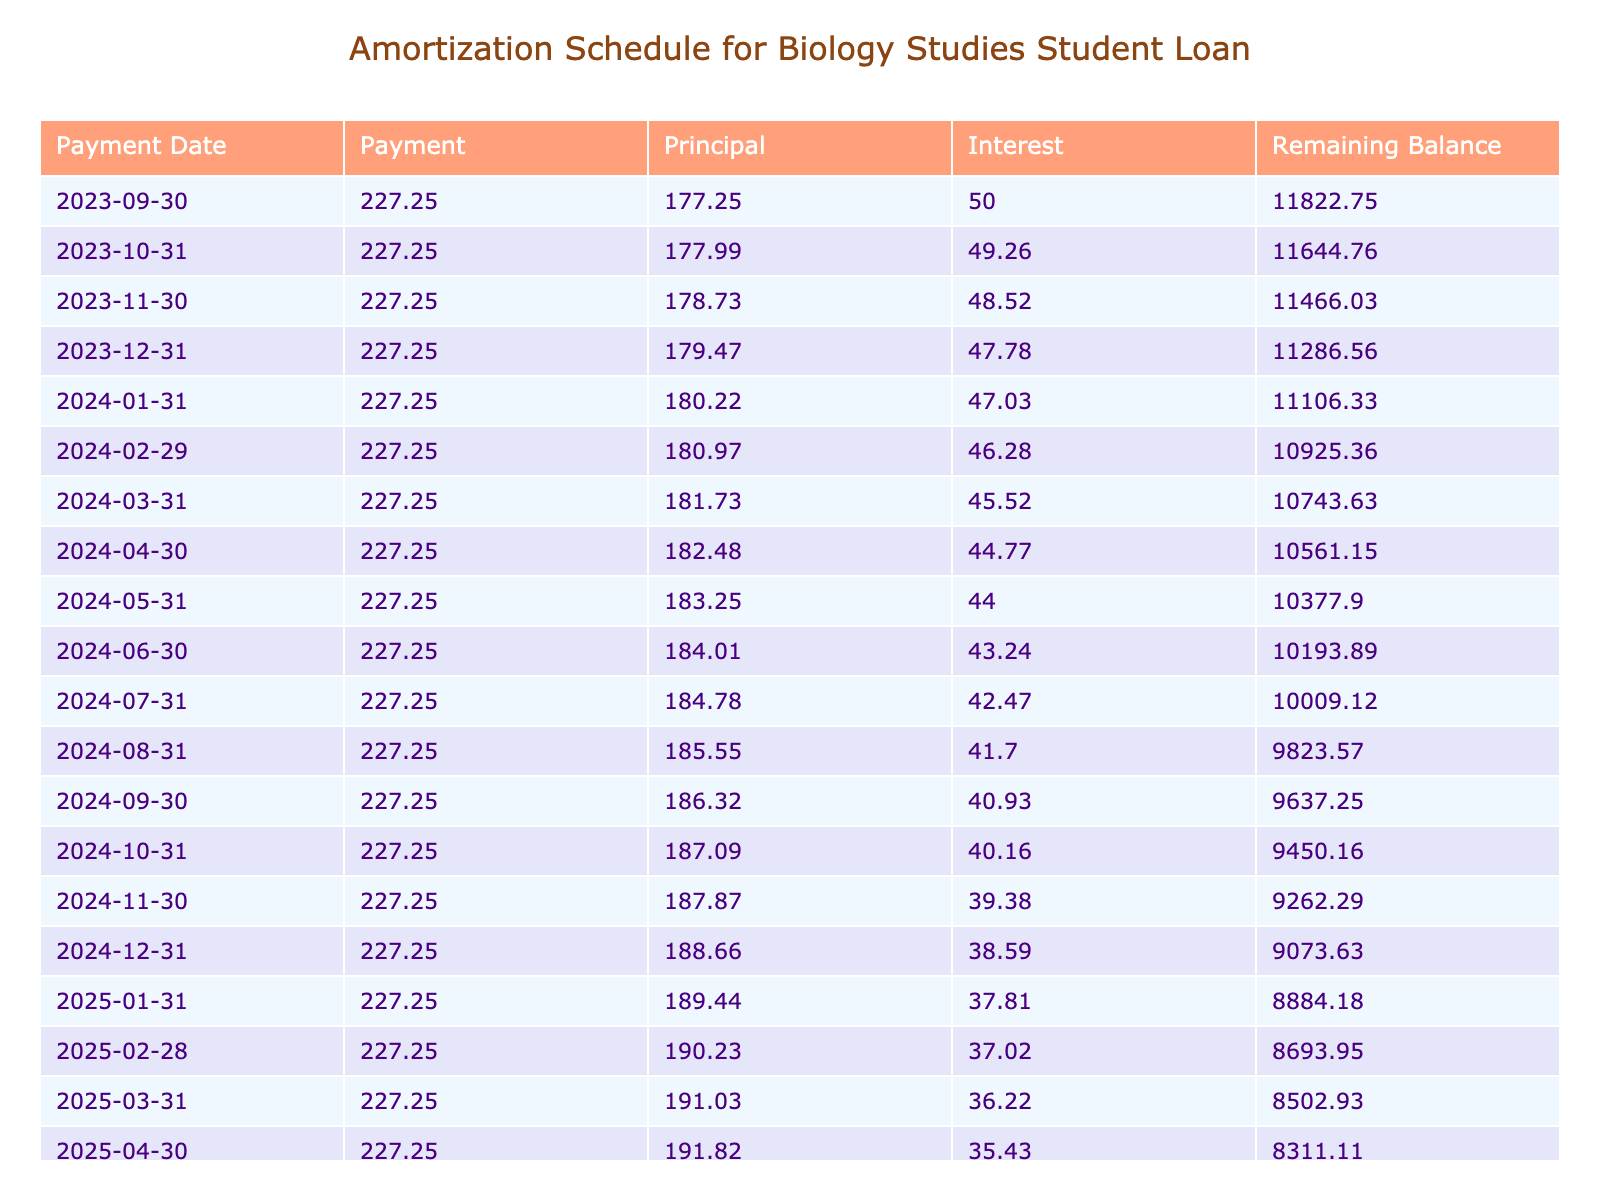What is the total loan amount taken for studying abroad? The table indicates that the loan amount for studying abroad is listed under "Loan Amount" and shows a value of 12000.
Answer: 12000 What is the monthly payment amount? The table clearly states the monthly payment in the "Monthly Payment" column, which is 227.25.
Answer: 227.25 How much total interest will be paid over the loan term? The total interest paid is provided in the "Total Interest Paid" column as 1393.16.
Answer: 1393.16 Is the interest rate on the loan greater than 3%? The interest rate given in the table is 5%. Since 5% is greater than 3%, the answer is yes.
Answer: Yes What will be the remaining balance after the first payment? To find the remaining balance after the first payment, we subtract the principal paid during the first month from the original loan amount. Monthly payment is 227.25, the interest for the first month is calculated as 12000 * (5/100/12) = 50. The principal for the first payment is 227.25 - 50 = 177.25. Remaining balance = 12000 - 177.25 = 11822.75.
Answer: 11822.75 What is the average monthly payment over the loan term? The total monthly payment is constant at 227.25 for 60 months, so the average monthly payment is simply 227.25.
Answer: 227.25 How much more than the loan amount will be paid in total? The total amount paid is 13393.16, and the original loan amount is 12000. Therefore, the difference is 13393.16 - 12000 = 1393.16, which represents the total interest.
Answer: 1393.16 What is the remaining balance after the second payment? The second payment calculation involves the remaining balance after the first payment of 11822.75, with a new interest calculation. Interest for the second month = 11822.75 * (5/100/12) = 49.26. Principal = 227.25 - 49.26 = 177.99. New remaining balance = 11822.75 - 177.99 = 11644.76.
Answer: 11644.76 Is the total payment amount higher than twice the loan amount? The total payment of 13393.16 must be compared to twice the loan amount, which is 2 * 12000 = 24000. Since 13393.16 is less than 24000, the answer is no.
Answer: No 